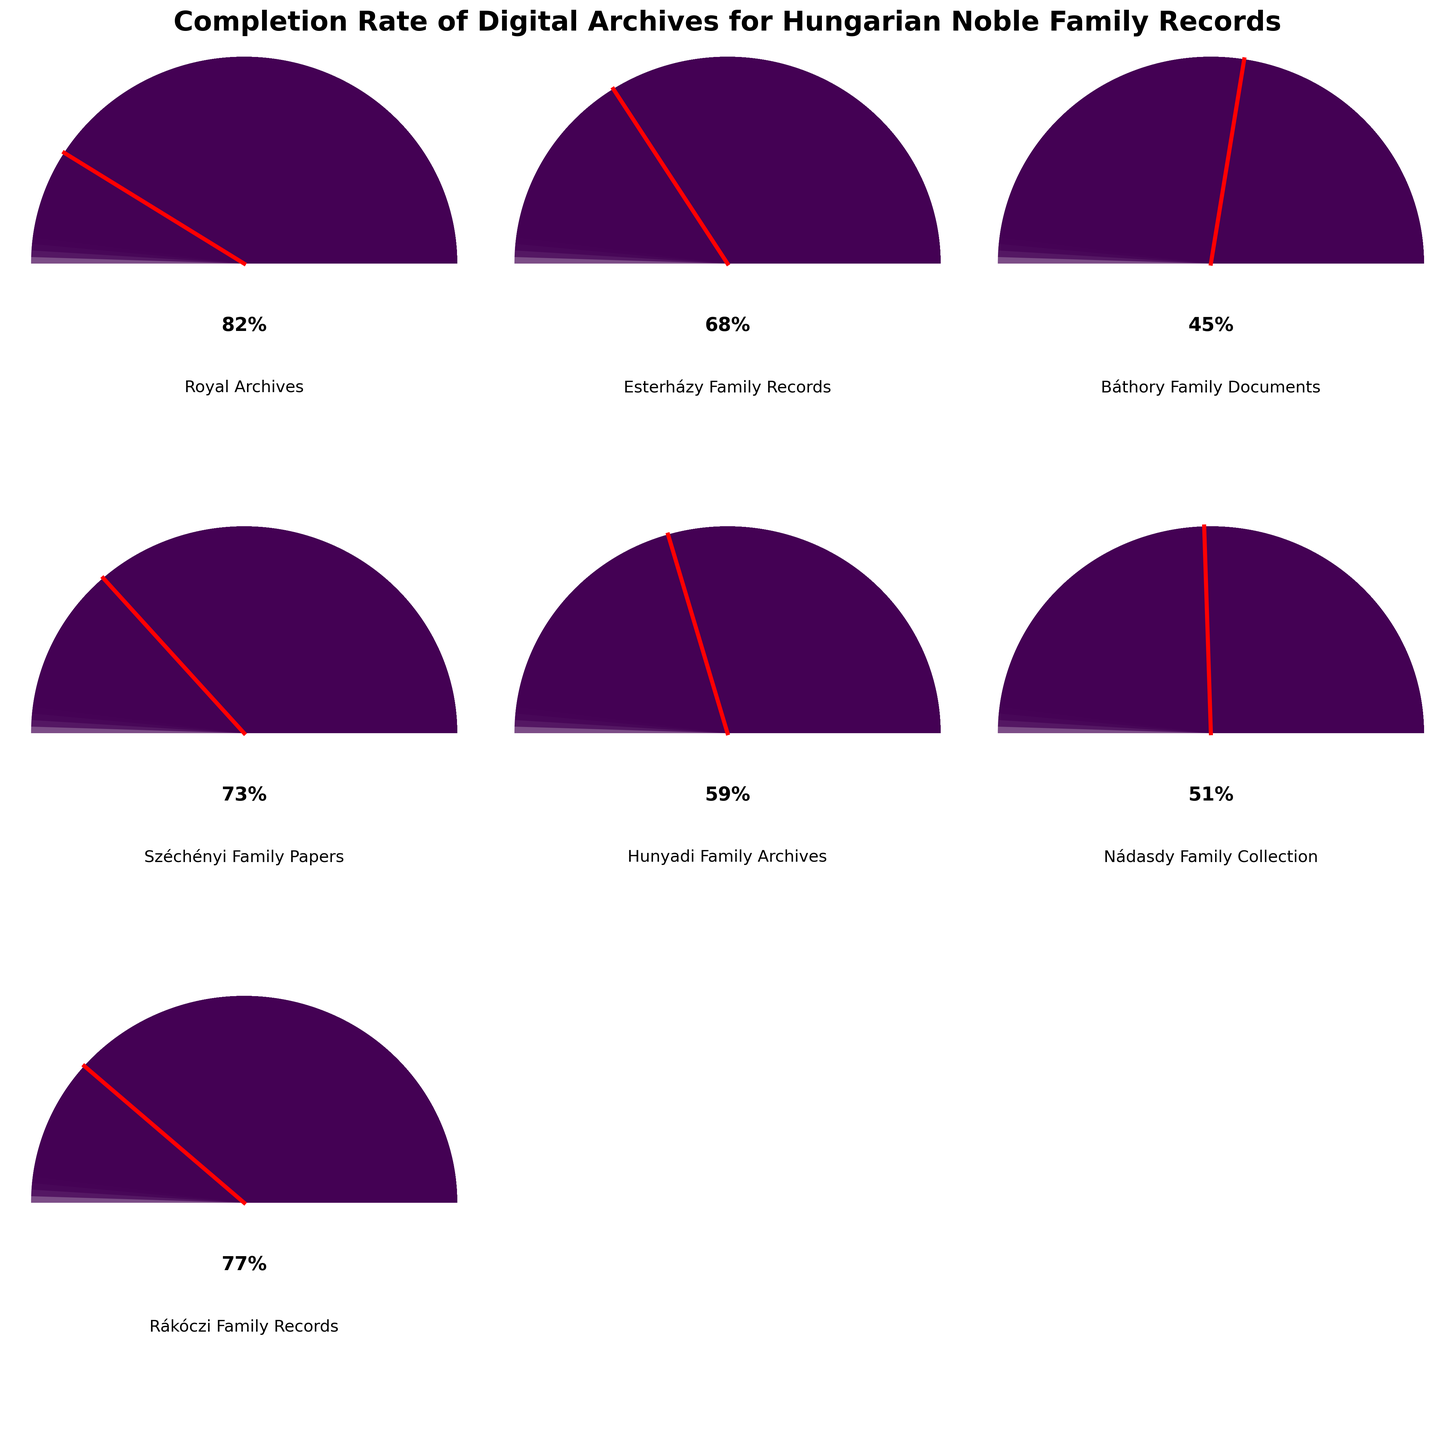Which family archive has the highest completion rate? By looking at the gauge charts, identify the category with the highest needle position. The Royal Archives gauge reads 82%, which is the highest among all categories.
Answer: Royal Archives Which family archive has the lowest completion rate? By checking the gauge charts, identify the category with the lowest needle position. The Báthory Family Documents have the lowest completion rate at 45%.
Answer: Báthory Family Documents What is the average completion rate across all archives? Add all completion rates and divide by the number of categories. (82 + 68 + 45 + 73 + 59 + 51 + 77) / 7 = 65
Answer: 65 How much higher is the completion rate of the Royal Archives compared to the Báthory Family Documents? Subtract the Báthory Family Documents' rate from the Royal Archives' rate. 82 - 45 = 37
Answer: 37 Which categories have a completion rate greater than 70%? Identify all categories with needles positioned higher than 70%. The Royal Archives (82%), Széchényi Family Papers (73%), and Rákóczi Family Records (77%) all meet this criterion.
Answer: Royal Archives, Széchényi Family Papers, Rákóczi Family Records What is the range of completion rates in the dataset? Subtract the lowest completion rate from the highest completion rate. 82 - 45 = 37
Answer: 37 Which family archive's completion rate is closest to the median rate? First, order the completion rates (45, 51, 59, 68, 73, 77, 82). The median rate is 68, thus the Esterházy Family Records (68) are the closest to the median.
Answer: Esterházy Family Records Do the majority of the family archives have a completion rate above 50%? There are 7 categories, so 4 or more should be above 50% to be considered a majority. (82, 68, 73, 59, 77) are above 50%, which makes 5 categories.
Answer: Yes What is the completion rate difference between the Esterházy and Nádasdy family archives? Subtract the Nádasdy Family Collection’s rate from the Esterházy Family Records' rate. 68 - 51 = 17
Answer: 17 